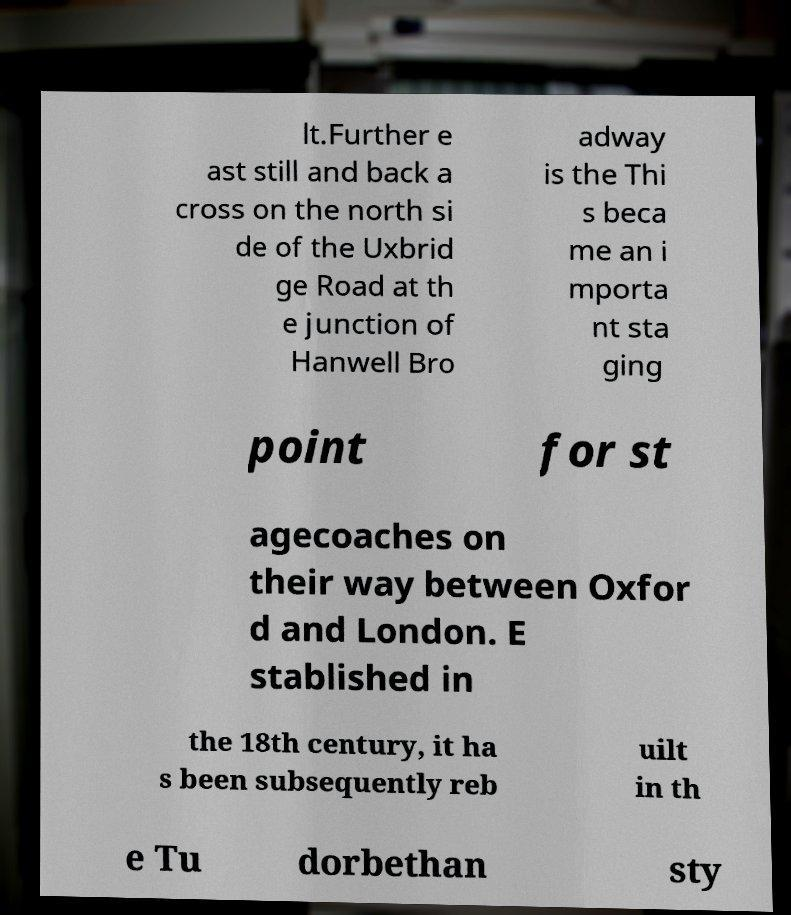Can you accurately transcribe the text from the provided image for me? lt.Further e ast still and back a cross on the north si de of the Uxbrid ge Road at th e junction of Hanwell Bro adway is the Thi s beca me an i mporta nt sta ging point for st agecoaches on their way between Oxfor d and London. E stablished in the 18th century, it ha s been subsequently reb uilt in th e Tu dorbethan sty 